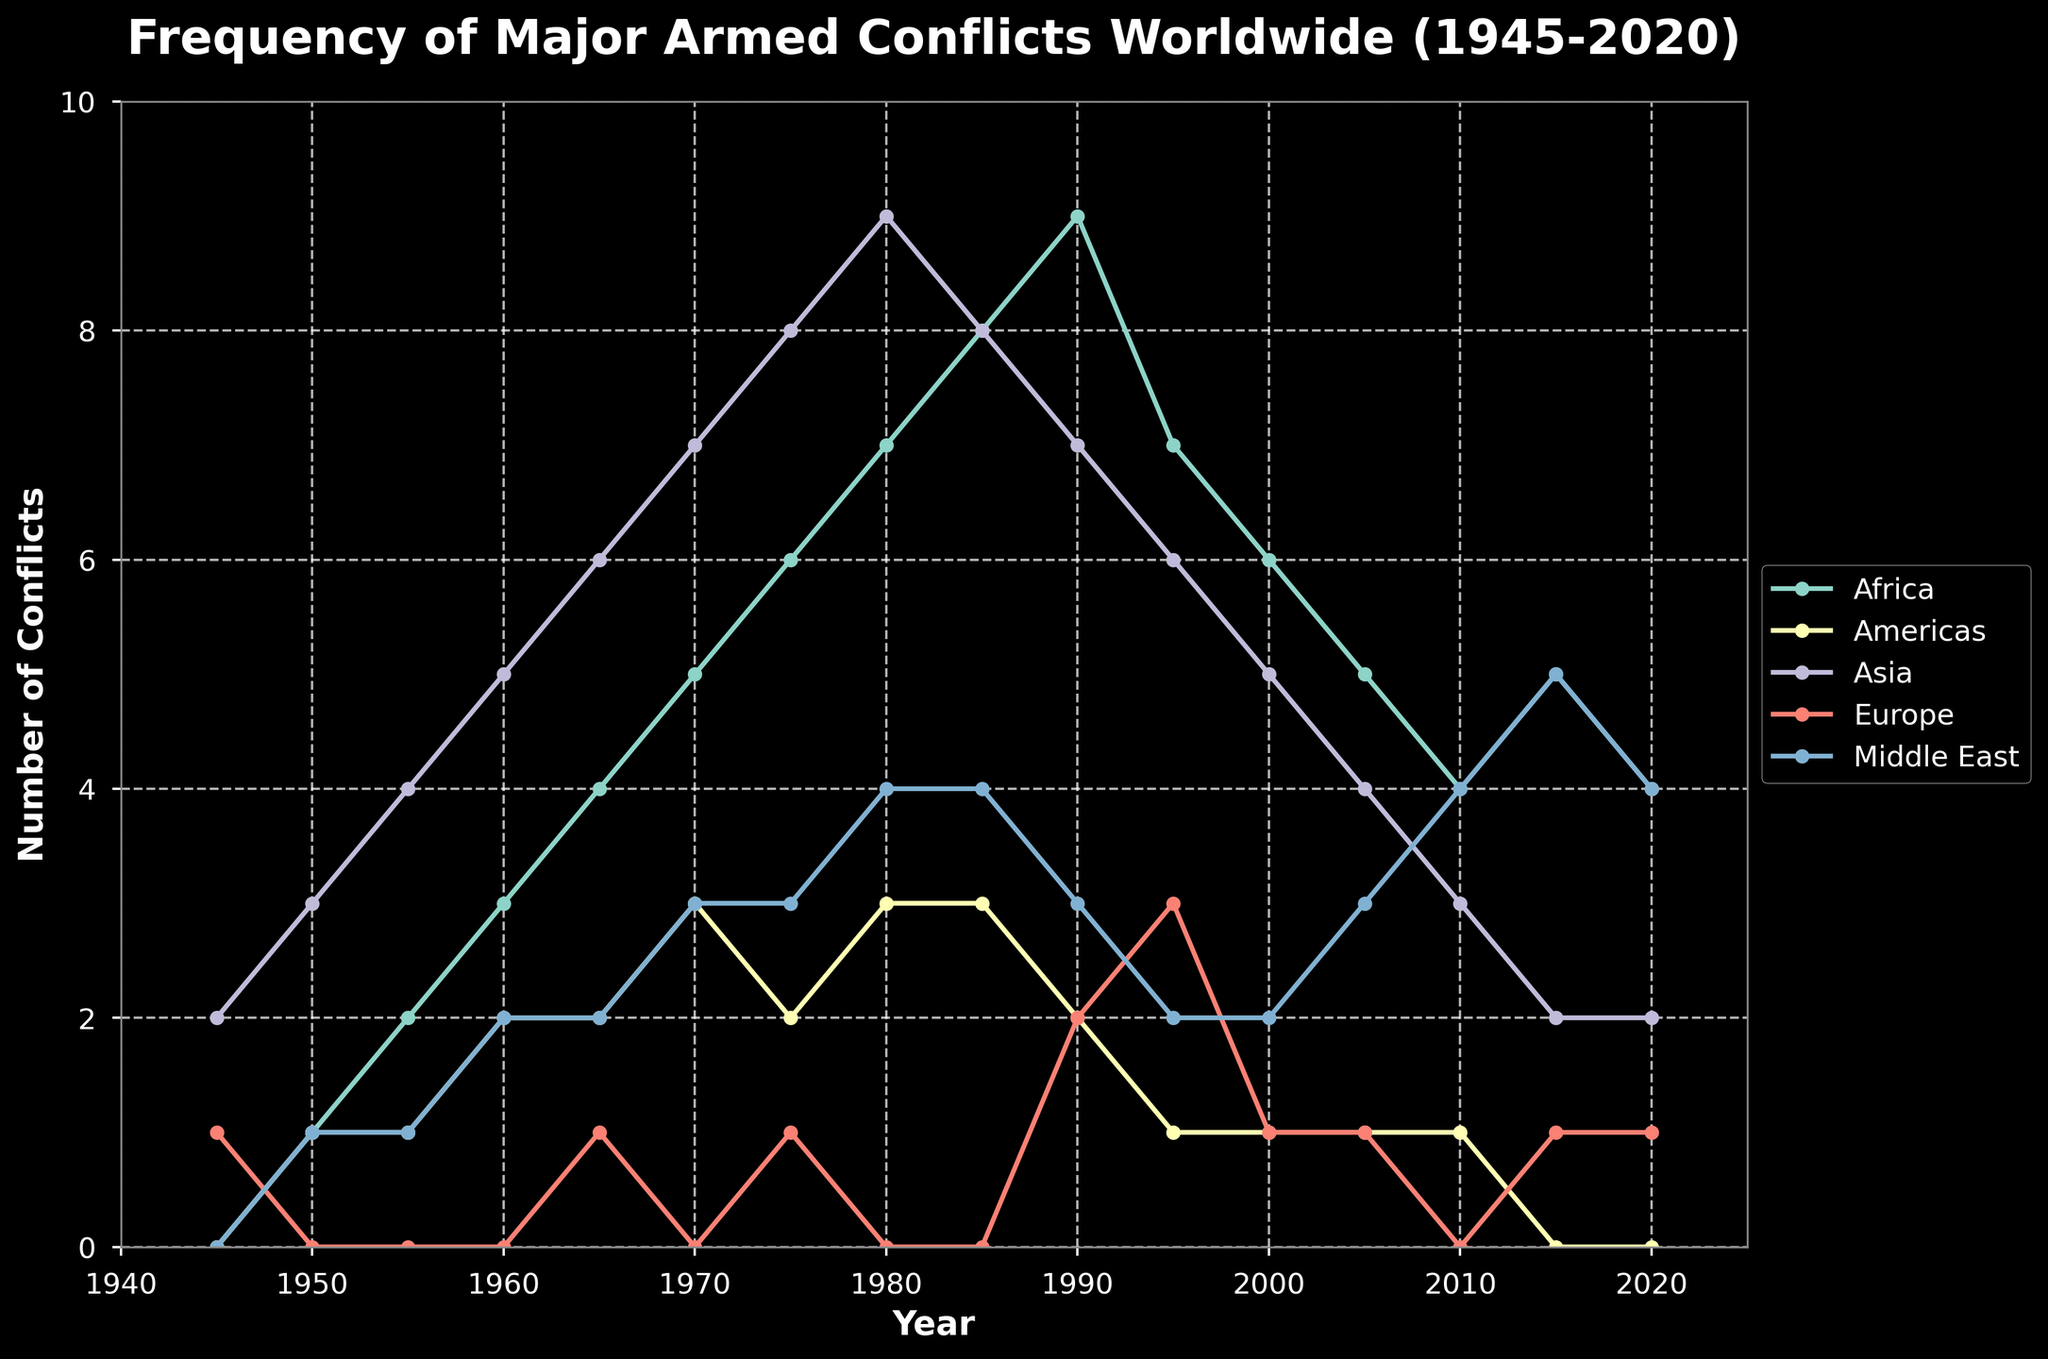What region had the highest number of major armed conflicts in 1980? In 1980, Asia had the highest number of major armed conflicts. This can be determined by looking at the peaks of the plotted lines for each region, where Asia's line reaches the highest point at 9 during that year.
Answer: Asia Which region saw the largest increase in the number of major armed conflicts between 1945 and 2020? To find the largest increase, calculate the difference in the value of major armed conflicts from 1945 to 2020 for each region. Africa increased from 0 to 4, Americas from 0 to 0, Asia from 2 to 2, Europe from 1 to 1, and Middle East from 0 to 4. Africa had the largest increase of 4.
Answer: Africa During which decade did Europe experience its highest number of major armed conflicts? Observing the line plot for Europe, the highest point is at 3 conflicts, and this occurred around 1995. Therefore, the 1990s were the decade when Europe experienced its highest number of armed conflicts.
Answer: 1990s Which region experienced a continuous increase in the number of major armed conflicts from 1945 to 1985? By visually analyzing the lines, Africa shows a continuous increase in the number of major armed conflicts, starting at 0 in 1945 and peaking at 8 in 1985 without any downward trends in between.
Answer: Africa Compare the trend of major armed conflicts in the Americas and the Middle East between 1960 and 2020. Throughout this period, the Americas' line remains fairly stable with conflicts ranging between 1 to 3 but generally descending, while the Middle East shows a clear upward trend, starting from 2 conflicts in 1960 and reaching a peak of 5 in 2015, showing overall growth.
Answer: The Middle East experienced an overall increase, while the Americas remained stable or slightly decreased Which regions had the same number of major armed conflicts in 2000? In the year 2000, both the Americas and Europe had the same number of major armed conflicts, which is 1. This is indicated by the overlapping points on the graph for both regions at that year.
Answer: Americas and Europe What was the total number of major armed conflicts across all regions in 1975? Adding the values for each region in 1975: Africa (6), Americas (2), Asia (8), Europe (1), and Middle East (3), the total number of major armed conflicts is 6 + 2 + 8 + 1 + 3 = 20.
Answer: 20 How did the number of major armed conflicts in Asia change between 1970 and 2010? In 1970, the number of major armed conflicts in Asia was 7, and in 2010, it was 3. This indicates a decrease of 4 major armed conflicts over this period.
Answer: Decreased by 4 What is the average number of major armed conflicts in the Middle East between the years 1945 and 2020? To find the average, sum up the number of conflicts in the Middle East for each year provided and divide by the total number of years (16): (0 + 1 + 1 + 2 + 2 + 3 + 3 + 4 + 4 + 3 + 2 + 2 + 3 + 4 + 5 + 4) / 16 = 39 / 16 = 2.4375
Answer: 2.44 